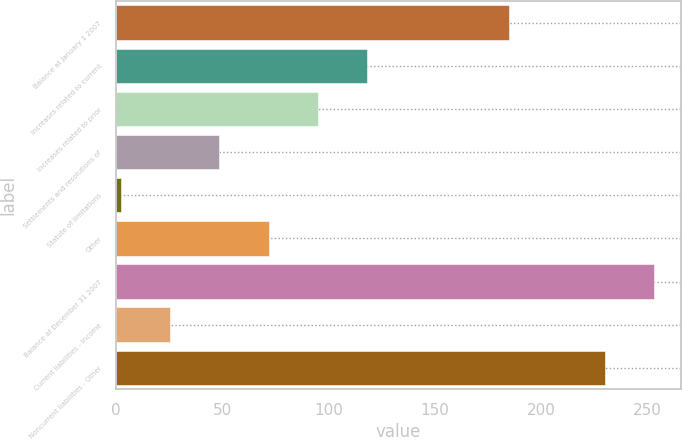Convert chart. <chart><loc_0><loc_0><loc_500><loc_500><bar_chart><fcel>Balance at January 1 2007<fcel>Increases related to current<fcel>Increases related to prior<fcel>Settlements and resolutions of<fcel>Statute of limitations<fcel>Other<fcel>Balance at December 31 2007<fcel>Current liabilities - Income<fcel>Noncurrent liabilities - Other<nl><fcel>185.1<fcel>118.1<fcel>94.96<fcel>48.68<fcel>2.4<fcel>71.82<fcel>253.14<fcel>25.54<fcel>230<nl></chart> 